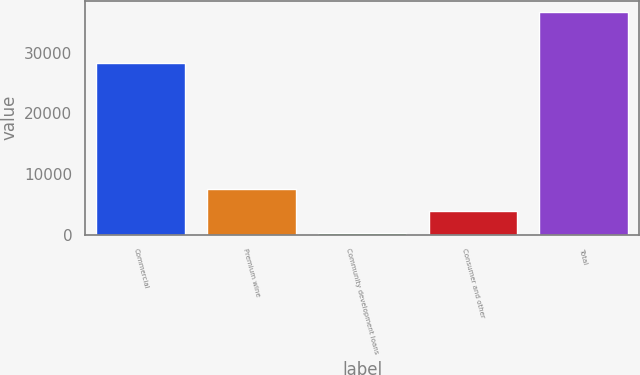Convert chart. <chart><loc_0><loc_0><loc_500><loc_500><bar_chart><fcel>Commercial<fcel>Premium wine<fcel>Community development loans<fcel>Consumer and other<fcel>Total<nl><fcel>28301<fcel>7593.8<fcel>296<fcel>3944.9<fcel>36785<nl></chart> 